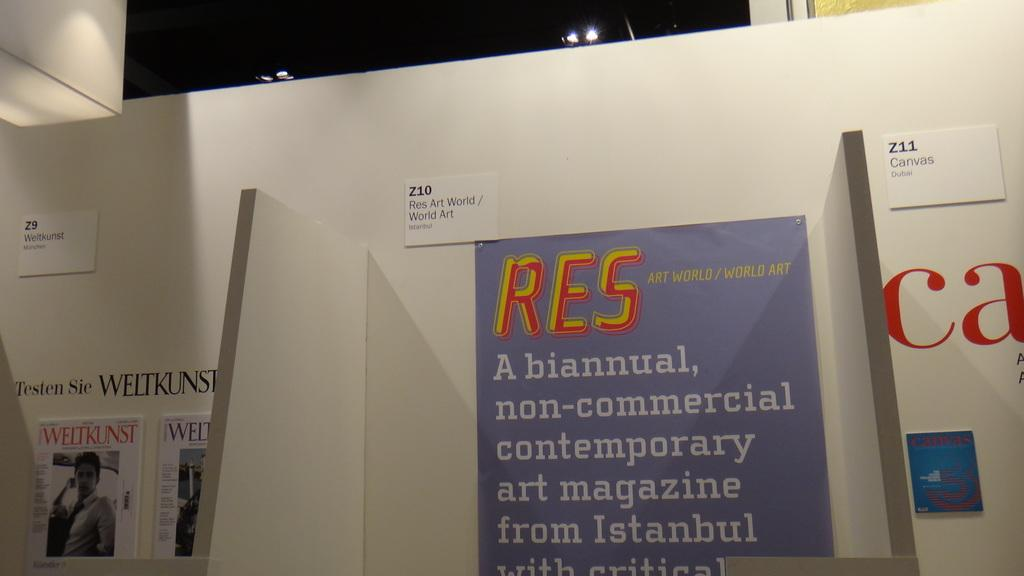Provide a one-sentence caption for the provided image. An art gallery with a purple piece in the middle that says RES on top. 